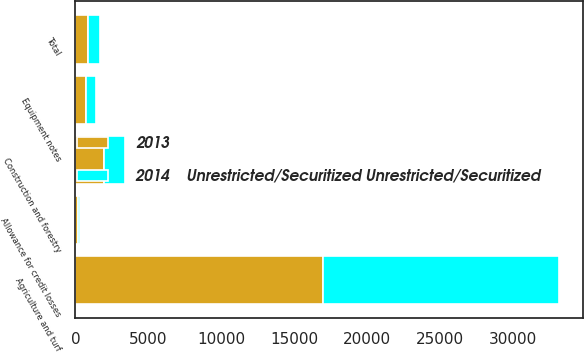Convert chart to OTSL. <chart><loc_0><loc_0><loc_500><loc_500><stacked_bar_chart><ecel><fcel>Agriculture and turf<fcel>Construction and forestry<fcel>Equipment notes<fcel>Total<fcel>Allowance for credit losses<nl><fcel>2013<fcel>16970<fcel>1951<fcel>753<fcel>889<fcel>161<nl><fcel>2014    Unrestricted/Securitized Unrestricted/Securitized<fcel>16209<fcel>1449<fcel>665<fcel>806<fcel>159<nl></chart> 